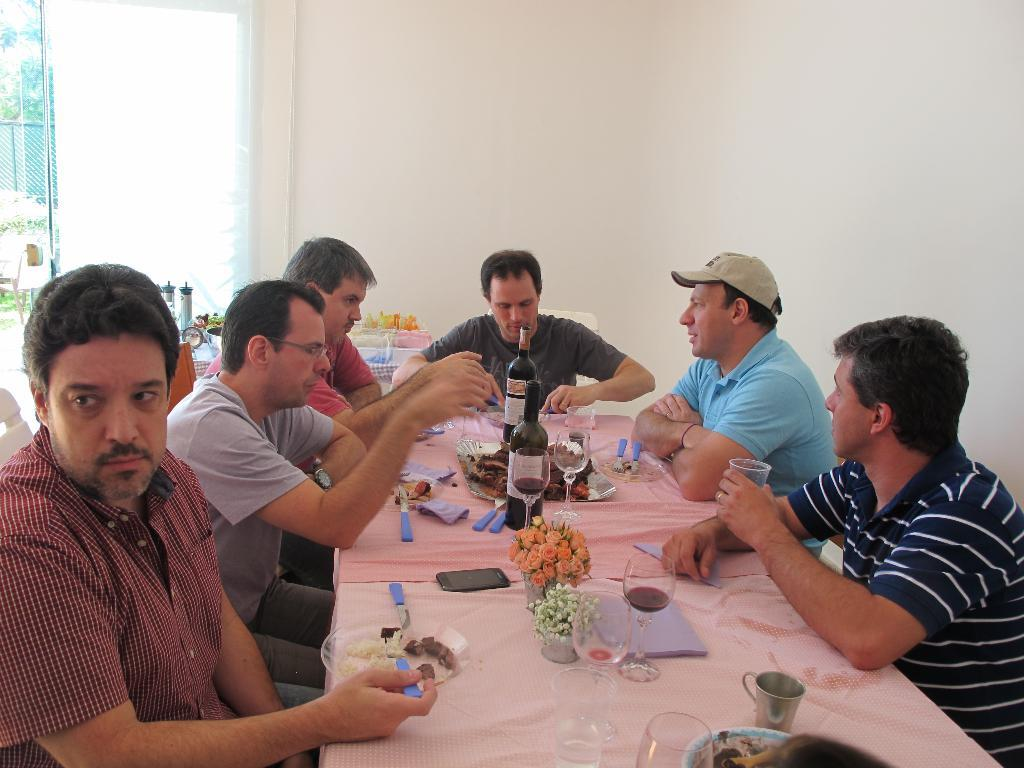How many people are in the image? There is a group of people in the image. What are the people doing in the image? The people are sitting in front of a table. What items can be seen on the table? There are bottles, glasses, plates, and a flower vase on the table. What is visible at the back side of the image? There is a wall visible at the back side of the image. What type of acoustics can be heard in the image? There is no information about the acoustics in the image, as it only shows a group of people sitting at a table with various items. --- 